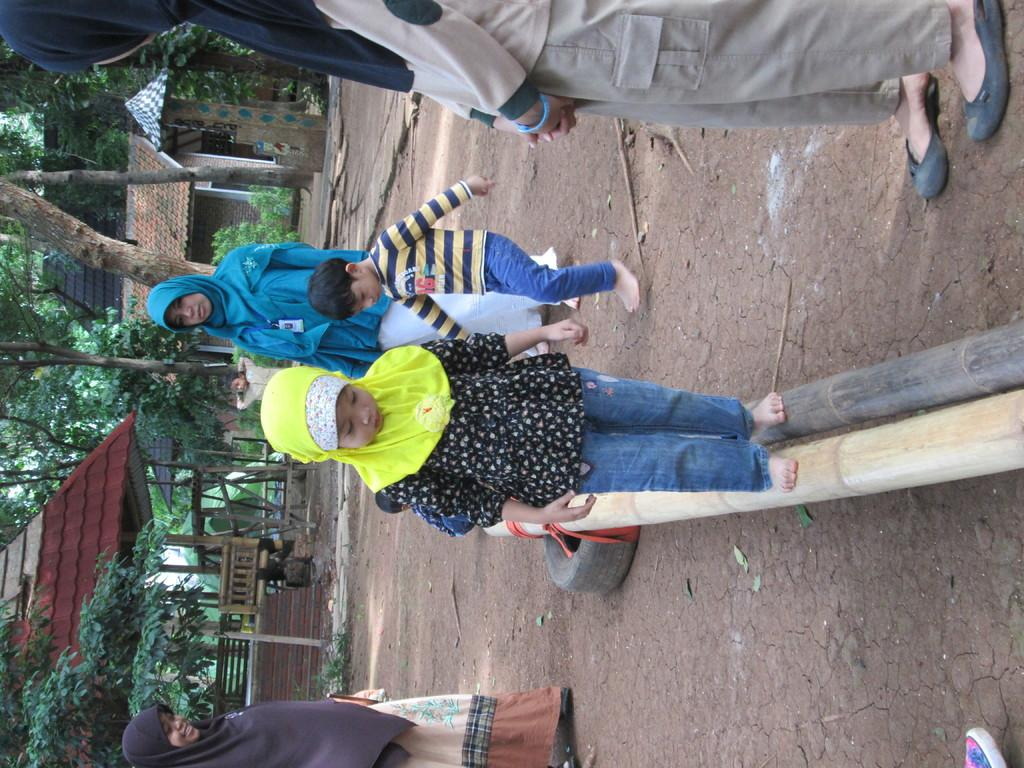What are the two kids in the image doing? The two kids in the image are walking. What are the other people in the image doing? There are persons standing in the image. What objects can be seen in the hands of the kids or the persons standing? Wooden sticks are visible in the image. What is the background of the image like? There are houses and trees in the background of the image. What type of art is displayed on the tree in the image? There is no art displayed on a tree in the image; there are only houses and trees in the background. 